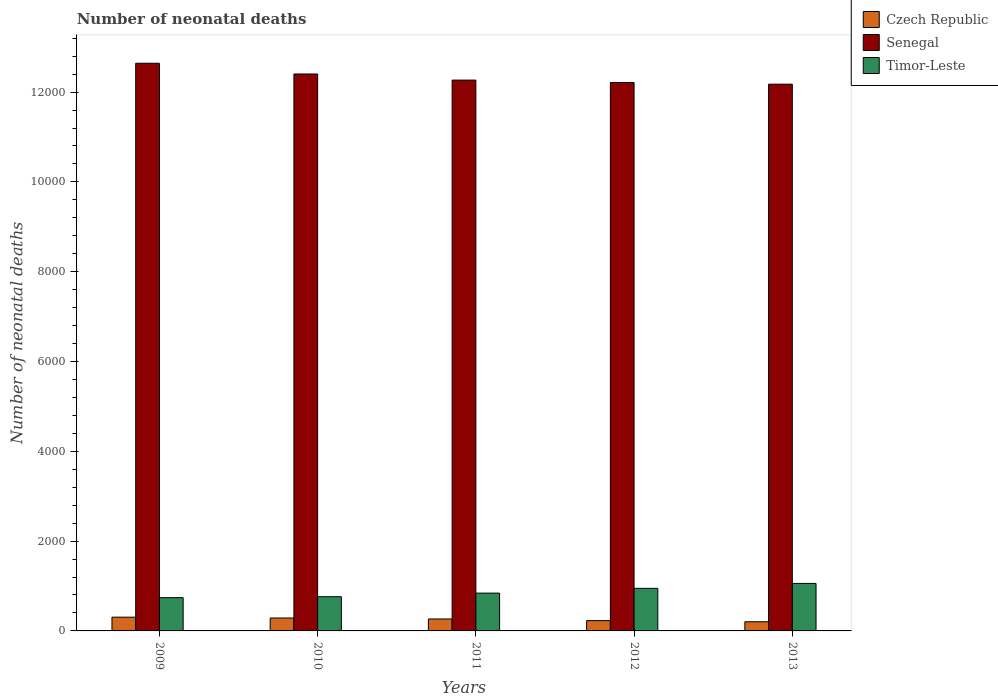How many different coloured bars are there?
Offer a terse response. 3. How many bars are there on the 5th tick from the left?
Make the answer very short. 3. How many bars are there on the 4th tick from the right?
Offer a terse response. 3. In how many cases, is the number of bars for a given year not equal to the number of legend labels?
Your answer should be compact. 0. What is the number of neonatal deaths in in Timor-Leste in 2012?
Ensure brevity in your answer.  948. Across all years, what is the maximum number of neonatal deaths in in Czech Republic?
Your answer should be compact. 306. Across all years, what is the minimum number of neonatal deaths in in Czech Republic?
Ensure brevity in your answer.  204. In which year was the number of neonatal deaths in in Czech Republic maximum?
Your answer should be very brief. 2009. In which year was the number of neonatal deaths in in Czech Republic minimum?
Offer a terse response. 2013. What is the total number of neonatal deaths in in Senegal in the graph?
Give a very brief answer. 6.17e+04. What is the difference between the number of neonatal deaths in in Timor-Leste in 2010 and that in 2011?
Your answer should be compact. -80. What is the difference between the number of neonatal deaths in in Senegal in 2011 and the number of neonatal deaths in in Czech Republic in 2010?
Provide a short and direct response. 1.20e+04. What is the average number of neonatal deaths in in Senegal per year?
Provide a succinct answer. 1.23e+04. In the year 2011, what is the difference between the number of neonatal deaths in in Senegal and number of neonatal deaths in in Timor-Leste?
Ensure brevity in your answer.  1.14e+04. In how many years, is the number of neonatal deaths in in Czech Republic greater than 10800?
Offer a very short reply. 0. What is the ratio of the number of neonatal deaths in in Timor-Leste in 2009 to that in 2010?
Make the answer very short. 0.97. Is the number of neonatal deaths in in Timor-Leste in 2009 less than that in 2013?
Provide a succinct answer. Yes. Is the difference between the number of neonatal deaths in in Senegal in 2012 and 2013 greater than the difference between the number of neonatal deaths in in Timor-Leste in 2012 and 2013?
Provide a short and direct response. Yes. What is the difference between the highest and the second highest number of neonatal deaths in in Senegal?
Provide a short and direct response. 239. What is the difference between the highest and the lowest number of neonatal deaths in in Czech Republic?
Ensure brevity in your answer.  102. In how many years, is the number of neonatal deaths in in Senegal greater than the average number of neonatal deaths in in Senegal taken over all years?
Your answer should be very brief. 2. Is the sum of the number of neonatal deaths in in Czech Republic in 2009 and 2012 greater than the maximum number of neonatal deaths in in Timor-Leste across all years?
Ensure brevity in your answer.  No. What does the 1st bar from the left in 2013 represents?
Provide a short and direct response. Czech Republic. What does the 2nd bar from the right in 2012 represents?
Your response must be concise. Senegal. Is it the case that in every year, the sum of the number of neonatal deaths in in Czech Republic and number of neonatal deaths in in Senegal is greater than the number of neonatal deaths in in Timor-Leste?
Give a very brief answer. Yes. Are all the bars in the graph horizontal?
Your answer should be compact. No. How many years are there in the graph?
Provide a succinct answer. 5. What is the difference between two consecutive major ticks on the Y-axis?
Ensure brevity in your answer.  2000. Does the graph contain grids?
Your answer should be compact. No. What is the title of the graph?
Give a very brief answer. Number of neonatal deaths. Does "Yemen, Rep." appear as one of the legend labels in the graph?
Your answer should be very brief. No. What is the label or title of the X-axis?
Keep it short and to the point. Years. What is the label or title of the Y-axis?
Keep it short and to the point. Number of neonatal deaths. What is the Number of neonatal deaths in Czech Republic in 2009?
Give a very brief answer. 306. What is the Number of neonatal deaths of Senegal in 2009?
Offer a very short reply. 1.26e+04. What is the Number of neonatal deaths in Timor-Leste in 2009?
Offer a very short reply. 741. What is the Number of neonatal deaths of Czech Republic in 2010?
Your answer should be compact. 288. What is the Number of neonatal deaths in Senegal in 2010?
Offer a terse response. 1.24e+04. What is the Number of neonatal deaths of Timor-Leste in 2010?
Give a very brief answer. 762. What is the Number of neonatal deaths in Czech Republic in 2011?
Your answer should be very brief. 266. What is the Number of neonatal deaths in Senegal in 2011?
Your answer should be compact. 1.23e+04. What is the Number of neonatal deaths in Timor-Leste in 2011?
Your answer should be very brief. 842. What is the Number of neonatal deaths of Czech Republic in 2012?
Provide a short and direct response. 229. What is the Number of neonatal deaths in Senegal in 2012?
Provide a short and direct response. 1.22e+04. What is the Number of neonatal deaths in Timor-Leste in 2012?
Your response must be concise. 948. What is the Number of neonatal deaths in Czech Republic in 2013?
Make the answer very short. 204. What is the Number of neonatal deaths of Senegal in 2013?
Keep it short and to the point. 1.22e+04. What is the Number of neonatal deaths in Timor-Leste in 2013?
Your response must be concise. 1058. Across all years, what is the maximum Number of neonatal deaths of Czech Republic?
Provide a short and direct response. 306. Across all years, what is the maximum Number of neonatal deaths of Senegal?
Provide a short and direct response. 1.26e+04. Across all years, what is the maximum Number of neonatal deaths in Timor-Leste?
Provide a short and direct response. 1058. Across all years, what is the minimum Number of neonatal deaths in Czech Republic?
Provide a succinct answer. 204. Across all years, what is the minimum Number of neonatal deaths in Senegal?
Your answer should be compact. 1.22e+04. Across all years, what is the minimum Number of neonatal deaths of Timor-Leste?
Provide a succinct answer. 741. What is the total Number of neonatal deaths of Czech Republic in the graph?
Your response must be concise. 1293. What is the total Number of neonatal deaths in Senegal in the graph?
Offer a very short reply. 6.17e+04. What is the total Number of neonatal deaths of Timor-Leste in the graph?
Keep it short and to the point. 4351. What is the difference between the Number of neonatal deaths in Senegal in 2009 and that in 2010?
Your answer should be compact. 239. What is the difference between the Number of neonatal deaths in Czech Republic in 2009 and that in 2011?
Make the answer very short. 40. What is the difference between the Number of neonatal deaths in Senegal in 2009 and that in 2011?
Offer a very short reply. 375. What is the difference between the Number of neonatal deaths of Timor-Leste in 2009 and that in 2011?
Make the answer very short. -101. What is the difference between the Number of neonatal deaths of Czech Republic in 2009 and that in 2012?
Make the answer very short. 77. What is the difference between the Number of neonatal deaths of Senegal in 2009 and that in 2012?
Your response must be concise. 428. What is the difference between the Number of neonatal deaths in Timor-Leste in 2009 and that in 2012?
Your response must be concise. -207. What is the difference between the Number of neonatal deaths of Czech Republic in 2009 and that in 2013?
Keep it short and to the point. 102. What is the difference between the Number of neonatal deaths in Senegal in 2009 and that in 2013?
Your answer should be very brief. 466. What is the difference between the Number of neonatal deaths in Timor-Leste in 2009 and that in 2013?
Make the answer very short. -317. What is the difference between the Number of neonatal deaths of Czech Republic in 2010 and that in 2011?
Make the answer very short. 22. What is the difference between the Number of neonatal deaths in Senegal in 2010 and that in 2011?
Provide a succinct answer. 136. What is the difference between the Number of neonatal deaths in Timor-Leste in 2010 and that in 2011?
Your answer should be very brief. -80. What is the difference between the Number of neonatal deaths in Senegal in 2010 and that in 2012?
Ensure brevity in your answer.  189. What is the difference between the Number of neonatal deaths in Timor-Leste in 2010 and that in 2012?
Provide a succinct answer. -186. What is the difference between the Number of neonatal deaths of Czech Republic in 2010 and that in 2013?
Give a very brief answer. 84. What is the difference between the Number of neonatal deaths of Senegal in 2010 and that in 2013?
Give a very brief answer. 227. What is the difference between the Number of neonatal deaths of Timor-Leste in 2010 and that in 2013?
Your answer should be compact. -296. What is the difference between the Number of neonatal deaths of Czech Republic in 2011 and that in 2012?
Offer a terse response. 37. What is the difference between the Number of neonatal deaths in Senegal in 2011 and that in 2012?
Keep it short and to the point. 53. What is the difference between the Number of neonatal deaths in Timor-Leste in 2011 and that in 2012?
Your answer should be compact. -106. What is the difference between the Number of neonatal deaths of Czech Republic in 2011 and that in 2013?
Your answer should be very brief. 62. What is the difference between the Number of neonatal deaths of Senegal in 2011 and that in 2013?
Provide a short and direct response. 91. What is the difference between the Number of neonatal deaths in Timor-Leste in 2011 and that in 2013?
Give a very brief answer. -216. What is the difference between the Number of neonatal deaths in Czech Republic in 2012 and that in 2013?
Offer a terse response. 25. What is the difference between the Number of neonatal deaths of Timor-Leste in 2012 and that in 2013?
Give a very brief answer. -110. What is the difference between the Number of neonatal deaths of Czech Republic in 2009 and the Number of neonatal deaths of Senegal in 2010?
Keep it short and to the point. -1.21e+04. What is the difference between the Number of neonatal deaths of Czech Republic in 2009 and the Number of neonatal deaths of Timor-Leste in 2010?
Ensure brevity in your answer.  -456. What is the difference between the Number of neonatal deaths of Senegal in 2009 and the Number of neonatal deaths of Timor-Leste in 2010?
Give a very brief answer. 1.19e+04. What is the difference between the Number of neonatal deaths in Czech Republic in 2009 and the Number of neonatal deaths in Senegal in 2011?
Your answer should be very brief. -1.20e+04. What is the difference between the Number of neonatal deaths of Czech Republic in 2009 and the Number of neonatal deaths of Timor-Leste in 2011?
Your answer should be very brief. -536. What is the difference between the Number of neonatal deaths of Senegal in 2009 and the Number of neonatal deaths of Timor-Leste in 2011?
Your response must be concise. 1.18e+04. What is the difference between the Number of neonatal deaths in Czech Republic in 2009 and the Number of neonatal deaths in Senegal in 2012?
Your response must be concise. -1.19e+04. What is the difference between the Number of neonatal deaths in Czech Republic in 2009 and the Number of neonatal deaths in Timor-Leste in 2012?
Provide a succinct answer. -642. What is the difference between the Number of neonatal deaths in Senegal in 2009 and the Number of neonatal deaths in Timor-Leste in 2012?
Provide a short and direct response. 1.17e+04. What is the difference between the Number of neonatal deaths of Czech Republic in 2009 and the Number of neonatal deaths of Senegal in 2013?
Keep it short and to the point. -1.19e+04. What is the difference between the Number of neonatal deaths of Czech Republic in 2009 and the Number of neonatal deaths of Timor-Leste in 2013?
Offer a terse response. -752. What is the difference between the Number of neonatal deaths in Senegal in 2009 and the Number of neonatal deaths in Timor-Leste in 2013?
Keep it short and to the point. 1.16e+04. What is the difference between the Number of neonatal deaths in Czech Republic in 2010 and the Number of neonatal deaths in Senegal in 2011?
Offer a terse response. -1.20e+04. What is the difference between the Number of neonatal deaths in Czech Republic in 2010 and the Number of neonatal deaths in Timor-Leste in 2011?
Make the answer very short. -554. What is the difference between the Number of neonatal deaths of Senegal in 2010 and the Number of neonatal deaths of Timor-Leste in 2011?
Make the answer very short. 1.16e+04. What is the difference between the Number of neonatal deaths in Czech Republic in 2010 and the Number of neonatal deaths in Senegal in 2012?
Keep it short and to the point. -1.19e+04. What is the difference between the Number of neonatal deaths in Czech Republic in 2010 and the Number of neonatal deaths in Timor-Leste in 2012?
Your answer should be very brief. -660. What is the difference between the Number of neonatal deaths of Senegal in 2010 and the Number of neonatal deaths of Timor-Leste in 2012?
Ensure brevity in your answer.  1.15e+04. What is the difference between the Number of neonatal deaths in Czech Republic in 2010 and the Number of neonatal deaths in Senegal in 2013?
Offer a very short reply. -1.19e+04. What is the difference between the Number of neonatal deaths of Czech Republic in 2010 and the Number of neonatal deaths of Timor-Leste in 2013?
Make the answer very short. -770. What is the difference between the Number of neonatal deaths in Senegal in 2010 and the Number of neonatal deaths in Timor-Leste in 2013?
Make the answer very short. 1.13e+04. What is the difference between the Number of neonatal deaths in Czech Republic in 2011 and the Number of neonatal deaths in Senegal in 2012?
Make the answer very short. -1.19e+04. What is the difference between the Number of neonatal deaths of Czech Republic in 2011 and the Number of neonatal deaths of Timor-Leste in 2012?
Give a very brief answer. -682. What is the difference between the Number of neonatal deaths in Senegal in 2011 and the Number of neonatal deaths in Timor-Leste in 2012?
Your answer should be very brief. 1.13e+04. What is the difference between the Number of neonatal deaths of Czech Republic in 2011 and the Number of neonatal deaths of Senegal in 2013?
Give a very brief answer. -1.19e+04. What is the difference between the Number of neonatal deaths in Czech Republic in 2011 and the Number of neonatal deaths in Timor-Leste in 2013?
Keep it short and to the point. -792. What is the difference between the Number of neonatal deaths of Senegal in 2011 and the Number of neonatal deaths of Timor-Leste in 2013?
Offer a terse response. 1.12e+04. What is the difference between the Number of neonatal deaths of Czech Republic in 2012 and the Number of neonatal deaths of Senegal in 2013?
Make the answer very short. -1.19e+04. What is the difference between the Number of neonatal deaths of Czech Republic in 2012 and the Number of neonatal deaths of Timor-Leste in 2013?
Your answer should be compact. -829. What is the difference between the Number of neonatal deaths of Senegal in 2012 and the Number of neonatal deaths of Timor-Leste in 2013?
Give a very brief answer. 1.12e+04. What is the average Number of neonatal deaths of Czech Republic per year?
Your answer should be compact. 258.6. What is the average Number of neonatal deaths of Senegal per year?
Provide a short and direct response. 1.23e+04. What is the average Number of neonatal deaths in Timor-Leste per year?
Offer a terse response. 870.2. In the year 2009, what is the difference between the Number of neonatal deaths of Czech Republic and Number of neonatal deaths of Senegal?
Keep it short and to the point. -1.23e+04. In the year 2009, what is the difference between the Number of neonatal deaths in Czech Republic and Number of neonatal deaths in Timor-Leste?
Your answer should be very brief. -435. In the year 2009, what is the difference between the Number of neonatal deaths in Senegal and Number of neonatal deaths in Timor-Leste?
Keep it short and to the point. 1.19e+04. In the year 2010, what is the difference between the Number of neonatal deaths in Czech Republic and Number of neonatal deaths in Senegal?
Your response must be concise. -1.21e+04. In the year 2010, what is the difference between the Number of neonatal deaths in Czech Republic and Number of neonatal deaths in Timor-Leste?
Keep it short and to the point. -474. In the year 2010, what is the difference between the Number of neonatal deaths in Senegal and Number of neonatal deaths in Timor-Leste?
Your answer should be compact. 1.16e+04. In the year 2011, what is the difference between the Number of neonatal deaths of Czech Republic and Number of neonatal deaths of Senegal?
Your answer should be very brief. -1.20e+04. In the year 2011, what is the difference between the Number of neonatal deaths of Czech Republic and Number of neonatal deaths of Timor-Leste?
Keep it short and to the point. -576. In the year 2011, what is the difference between the Number of neonatal deaths in Senegal and Number of neonatal deaths in Timor-Leste?
Make the answer very short. 1.14e+04. In the year 2012, what is the difference between the Number of neonatal deaths of Czech Republic and Number of neonatal deaths of Senegal?
Offer a terse response. -1.20e+04. In the year 2012, what is the difference between the Number of neonatal deaths in Czech Republic and Number of neonatal deaths in Timor-Leste?
Give a very brief answer. -719. In the year 2012, what is the difference between the Number of neonatal deaths of Senegal and Number of neonatal deaths of Timor-Leste?
Make the answer very short. 1.13e+04. In the year 2013, what is the difference between the Number of neonatal deaths in Czech Republic and Number of neonatal deaths in Senegal?
Make the answer very short. -1.20e+04. In the year 2013, what is the difference between the Number of neonatal deaths in Czech Republic and Number of neonatal deaths in Timor-Leste?
Provide a short and direct response. -854. In the year 2013, what is the difference between the Number of neonatal deaths in Senegal and Number of neonatal deaths in Timor-Leste?
Keep it short and to the point. 1.11e+04. What is the ratio of the Number of neonatal deaths of Czech Republic in 2009 to that in 2010?
Make the answer very short. 1.06. What is the ratio of the Number of neonatal deaths of Senegal in 2009 to that in 2010?
Your response must be concise. 1.02. What is the ratio of the Number of neonatal deaths of Timor-Leste in 2009 to that in 2010?
Make the answer very short. 0.97. What is the ratio of the Number of neonatal deaths of Czech Republic in 2009 to that in 2011?
Ensure brevity in your answer.  1.15. What is the ratio of the Number of neonatal deaths of Senegal in 2009 to that in 2011?
Your answer should be very brief. 1.03. What is the ratio of the Number of neonatal deaths of Czech Republic in 2009 to that in 2012?
Give a very brief answer. 1.34. What is the ratio of the Number of neonatal deaths of Senegal in 2009 to that in 2012?
Your answer should be very brief. 1.03. What is the ratio of the Number of neonatal deaths in Timor-Leste in 2009 to that in 2012?
Keep it short and to the point. 0.78. What is the ratio of the Number of neonatal deaths of Senegal in 2009 to that in 2013?
Your response must be concise. 1.04. What is the ratio of the Number of neonatal deaths of Timor-Leste in 2009 to that in 2013?
Give a very brief answer. 0.7. What is the ratio of the Number of neonatal deaths of Czech Republic in 2010 to that in 2011?
Offer a terse response. 1.08. What is the ratio of the Number of neonatal deaths of Senegal in 2010 to that in 2011?
Keep it short and to the point. 1.01. What is the ratio of the Number of neonatal deaths in Timor-Leste in 2010 to that in 2011?
Your answer should be very brief. 0.91. What is the ratio of the Number of neonatal deaths of Czech Republic in 2010 to that in 2012?
Make the answer very short. 1.26. What is the ratio of the Number of neonatal deaths of Senegal in 2010 to that in 2012?
Your answer should be compact. 1.02. What is the ratio of the Number of neonatal deaths of Timor-Leste in 2010 to that in 2012?
Provide a succinct answer. 0.8. What is the ratio of the Number of neonatal deaths in Czech Republic in 2010 to that in 2013?
Your answer should be very brief. 1.41. What is the ratio of the Number of neonatal deaths of Senegal in 2010 to that in 2013?
Make the answer very short. 1.02. What is the ratio of the Number of neonatal deaths of Timor-Leste in 2010 to that in 2013?
Your answer should be compact. 0.72. What is the ratio of the Number of neonatal deaths of Czech Republic in 2011 to that in 2012?
Your answer should be compact. 1.16. What is the ratio of the Number of neonatal deaths of Timor-Leste in 2011 to that in 2012?
Make the answer very short. 0.89. What is the ratio of the Number of neonatal deaths of Czech Republic in 2011 to that in 2013?
Your answer should be very brief. 1.3. What is the ratio of the Number of neonatal deaths of Senegal in 2011 to that in 2013?
Your response must be concise. 1.01. What is the ratio of the Number of neonatal deaths in Timor-Leste in 2011 to that in 2013?
Offer a terse response. 0.8. What is the ratio of the Number of neonatal deaths in Czech Republic in 2012 to that in 2013?
Give a very brief answer. 1.12. What is the ratio of the Number of neonatal deaths of Timor-Leste in 2012 to that in 2013?
Provide a short and direct response. 0.9. What is the difference between the highest and the second highest Number of neonatal deaths of Senegal?
Offer a terse response. 239. What is the difference between the highest and the second highest Number of neonatal deaths in Timor-Leste?
Your answer should be very brief. 110. What is the difference between the highest and the lowest Number of neonatal deaths in Czech Republic?
Offer a terse response. 102. What is the difference between the highest and the lowest Number of neonatal deaths of Senegal?
Offer a very short reply. 466. What is the difference between the highest and the lowest Number of neonatal deaths in Timor-Leste?
Provide a succinct answer. 317. 